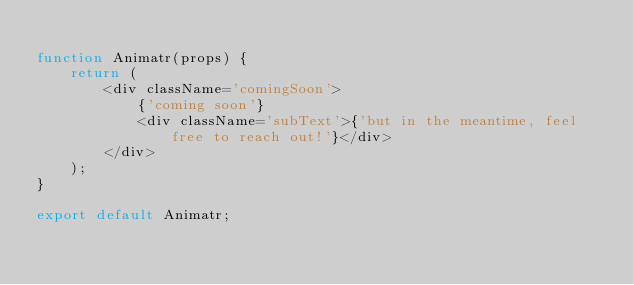<code> <loc_0><loc_0><loc_500><loc_500><_JavaScript_>
function Animatr(props) {
    return (
        <div className='comingSoon'>
            {'coming soon'}
            <div className='subText'>{'but in the meantime, feel free to reach out!'}</div>
        </div>
    );
}

export default Animatr;
</code> 